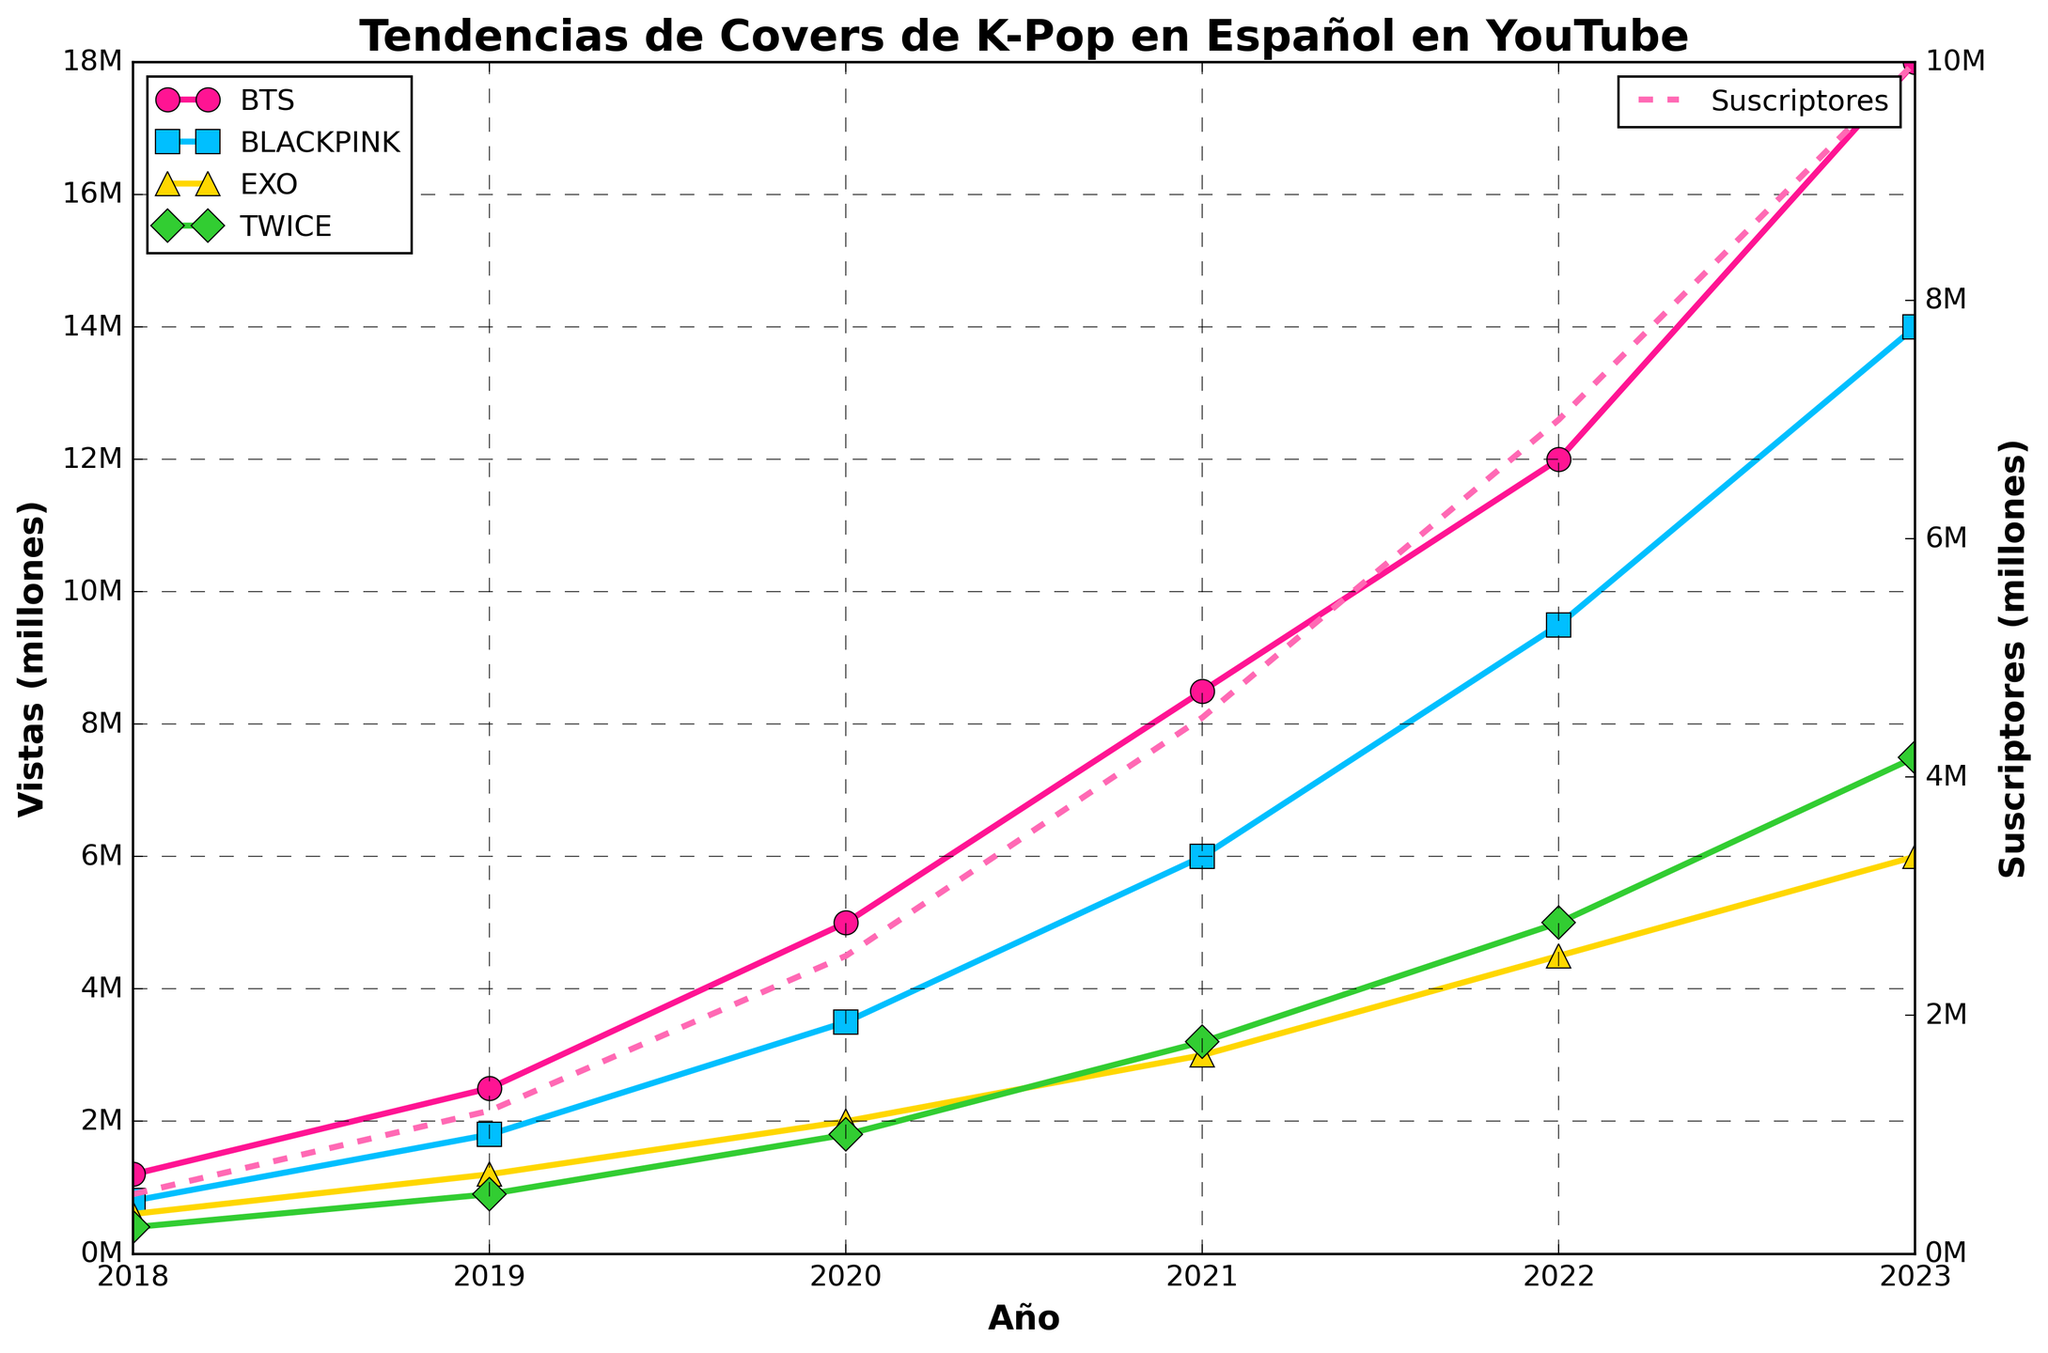What's the trend in BTS Covers Views from 2018 to 2023? Look at the pink line marked with circles. It starts at around 1.2M in 2018 and trends upward each year, ending at 18M in 2023.
Answer: It increases every year How do the views for EXO Covers in 2020 compare with those in 2023? Observe the yellow line marked with triangles. In 2020, it is at 2M views, and in 2023, it reaches 6M views.
Answer: 2023 views are higher Which group's cover views surpassed 10 million first, BTS or BLACKPINK? Look at the lines for BTS (pink) and BLACKPINK (blue). BTS crosses the 10M mark in 2021, whereas BLACKPINK reaches it in 2022.
Answer: BTS What's the combined total of TWICE Covers Views and EXO Covers Views in 2021? TWICE covers views are 3.2M and EXO covers views are 3M. Adding them together, 3.2M + 3.0M = 6.2M views.
Answer: 6.2M views Which cover group has the steepest increase in views between 2018 and 2022? Compare the slopes of the lines for BTS, BLACKPINK, EXO, and TWICE. The pink line for BTS shows the steepest rise from 1.2M in 2018 to 12M in 2022.
Answer: BTS What's the average number of views for BLACKPINK Covers from 2018 to 2023? Sum the views: 0.8M + 1.8M + 3.5M + 6M + 9.5M + 14M = 35.6M. There are 6 years, so 35.6M / 6 = 5.93M.
Answer: 5.93M views Which group's cover views saw the least growth from 2022 to 2023? Compare the changes between 2022 and 2023 for all groups. EXO's views increased from 4.5M to 6M, a 1.5M increase, which is the smallest change.
Answer: EXO What is the difference in subscriber count between 2019 and 2023? Look at the dotted line for subscribers. In 2019, there are 1.2M subscribers, and in 2023, there are 10M subscribers. The difference is 10M - 1.2M = 8.8M.
Answer: 8.8M subscribers Which year did TWICE Covers reach 5 million views? Follow the green line for TWICE. It reaches 5 million views in the year 2022.
Answer: 2022 How does the number of BTS Covers Views in 2019 compare to the number of BLACKPINK Covers Views in 2020? In 2019, BTS views are 2.5M. In 2020, BLACKPINK views are 3.5M. Comparing the two, BLACKPINK views in 2020 are higher.
Answer: BLACKPINK views in 2020 are higher 